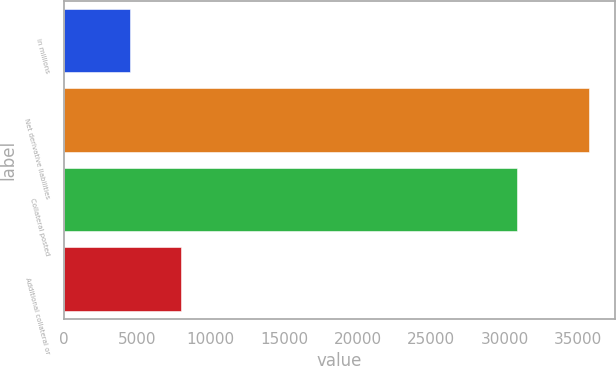<chart> <loc_0><loc_0><loc_500><loc_500><bar_chart><fcel>in millions<fcel>Net derivative liabilities<fcel>Collateral posted<fcel>Additional collateral or<nl><fcel>4541.2<fcel>35764<fcel>30824<fcel>8010.4<nl></chart> 